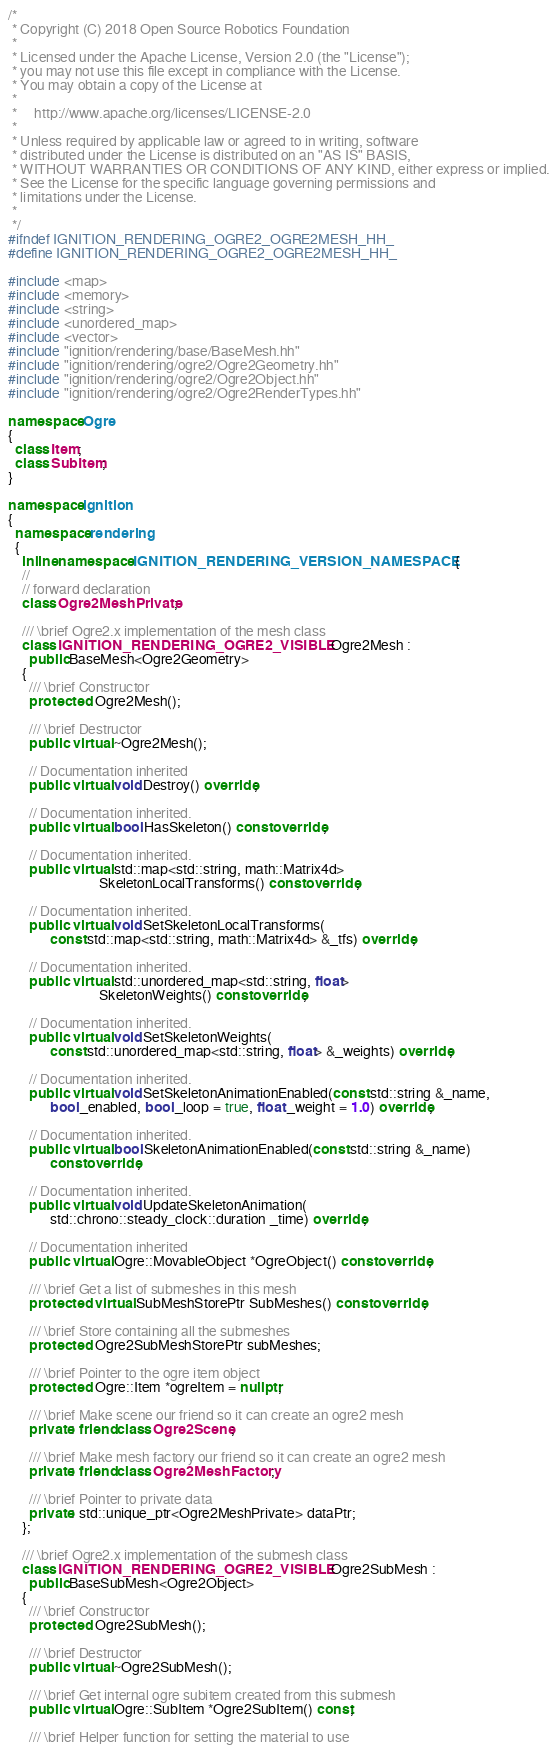<code> <loc_0><loc_0><loc_500><loc_500><_C++_>/*
 * Copyright (C) 2018 Open Source Robotics Foundation
 *
 * Licensed under the Apache License, Version 2.0 (the "License");
 * you may not use this file except in compliance with the License.
 * You may obtain a copy of the License at
 *
 *     http://www.apache.org/licenses/LICENSE-2.0
 *
 * Unless required by applicable law or agreed to in writing, software
 * distributed under the License is distributed on an "AS IS" BASIS,
 * WITHOUT WARRANTIES OR CONDITIONS OF ANY KIND, either express or implied.
 * See the License for the specific language governing permissions and
 * limitations under the License.
 *
 */
#ifndef IGNITION_RENDERING_OGRE2_OGRE2MESH_HH_
#define IGNITION_RENDERING_OGRE2_OGRE2MESH_HH_

#include <map>
#include <memory>
#include <string>
#include <unordered_map>
#include <vector>
#include "ignition/rendering/base/BaseMesh.hh"
#include "ignition/rendering/ogre2/Ogre2Geometry.hh"
#include "ignition/rendering/ogre2/Ogre2Object.hh"
#include "ignition/rendering/ogre2/Ogre2RenderTypes.hh"

namespace Ogre
{
  class Item;
  class SubItem;
}

namespace ignition
{
  namespace rendering
  {
    inline namespace IGNITION_RENDERING_VERSION_NAMESPACE {
    //
    // forward declaration
    class Ogre2MeshPrivate;

    /// \brief Ogre2.x implementation of the mesh class
    class IGNITION_RENDERING_OGRE2_VISIBLE Ogre2Mesh :
      public BaseMesh<Ogre2Geometry>
    {
      /// \brief Constructor
      protected: Ogre2Mesh();

      /// \brief Destructor
      public: virtual ~Ogre2Mesh();

      // Documentation inherited
      public: virtual void Destroy() override;

      // Documentation inherited.
      public: virtual bool HasSkeleton() const override;

      // Documentation inherited.
      public: virtual std::map<std::string, math::Matrix4d>
                          SkeletonLocalTransforms() const override;

      // Documentation inherited.
      public: virtual void SetSkeletonLocalTransforms(
            const std::map<std::string, math::Matrix4d> &_tfs) override;

      // Documentation inherited.
      public: virtual std::unordered_map<std::string, float>
                          SkeletonWeights() const override;

      // Documentation inherited.
      public: virtual void SetSkeletonWeights(
            const std::unordered_map<std::string, float> &_weights) override;

      // Documentation inherited.
      public: virtual void SetSkeletonAnimationEnabled(const std::string &_name,
            bool _enabled, bool _loop = true, float _weight = 1.0) override;

      // Documentation inherited.
      public: virtual bool SkeletonAnimationEnabled(const std::string &_name)
            const override;

      // Documentation inherited.
      public: virtual void UpdateSkeletonAnimation(
            std::chrono::steady_clock::duration _time) override;

      // Documentation inherited
      public: virtual Ogre::MovableObject *OgreObject() const override;

      /// \brief Get a list of submeshes in this mesh
      protected: virtual SubMeshStorePtr SubMeshes() const override;

      /// \brief Store containing all the submeshes
      protected: Ogre2SubMeshStorePtr subMeshes;

      /// \brief Pointer to the ogre item object
      protected: Ogre::Item *ogreItem = nullptr;

      /// \brief Make scene our friend so it can create an ogre2 mesh
      private: friend class Ogre2Scene;

      /// \brief Make mesh factory our friend so it can create an ogre2 mesh
      private: friend class Ogre2MeshFactory;

      /// \brief Pointer to private data
      private: std::unique_ptr<Ogre2MeshPrivate> dataPtr;
    };

    /// \brief Ogre2.x implementation of the submesh class
    class IGNITION_RENDERING_OGRE2_VISIBLE Ogre2SubMesh :
      public BaseSubMesh<Ogre2Object>
    {
      /// \brief Constructor
      protected: Ogre2SubMesh();

      /// \brief Destructor
      public: virtual ~Ogre2SubMesh();

      /// \brief Get internal ogre subitem created from this submesh
      public: virtual Ogre::SubItem *Ogre2SubItem() const;

      /// \brief Helper function for setting the material to use</code> 